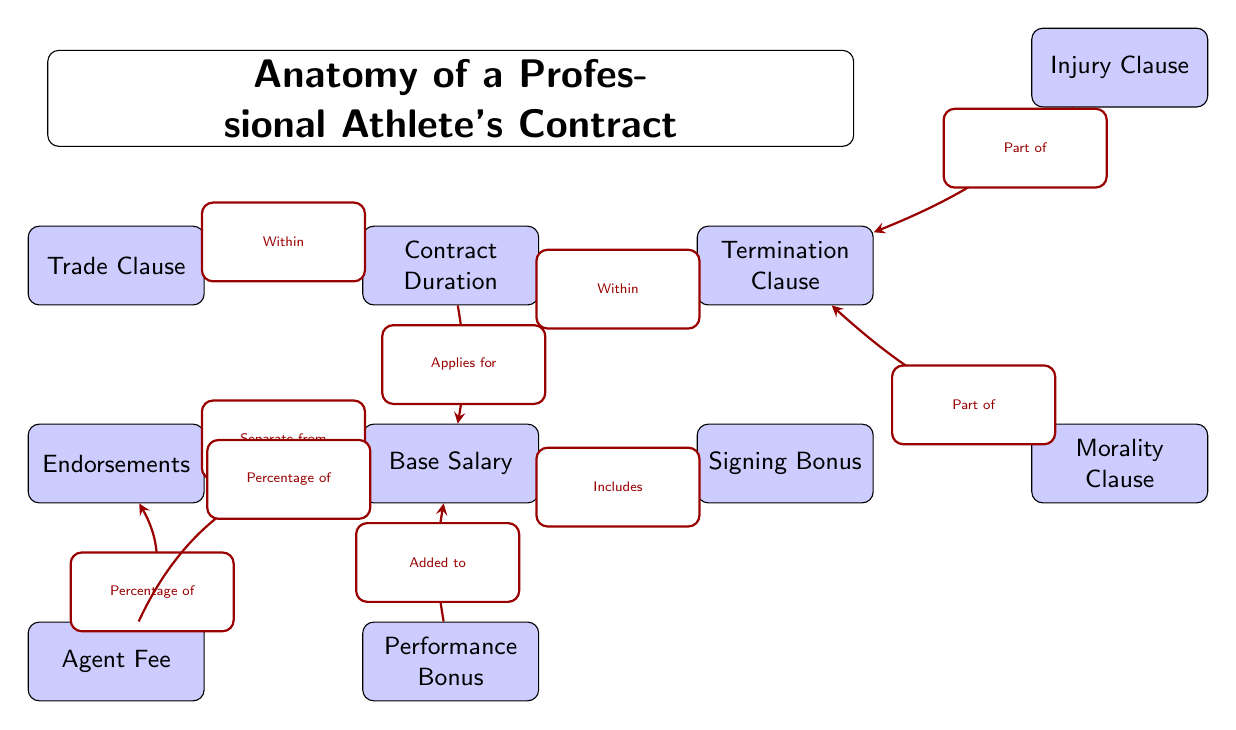What is the relationship between the signing bonus and base salary? The diagram shows an arrow labeled "Includes" pointing from the signing bonus to the base salary, indicating that the signing bonus is part of the base salary.
Answer: Includes How many clauses are part of the termination clause? The termination clause contains two clauses: injury clause and morality clause, as indicated by the arrows pointing to them from the termination clause.
Answer: Two What applies for the base salary? The diagram indicates that the contract duration applies for the base salary, as shown by the arrow labeled "Applies for."
Answer: Contract duration What percentage of endorsements does the agent fee represent? The diagram explicitly states that the agent fee is a percentage of the endorsements, as indicated by the arrow labeled "Percentage of."
Answer: Percentage of Which clause falls under the contract duration? The trade clause is indicated to be within the contract duration, as the arrow labeled "Within" directs from the contract duration to the trade clause.
Answer: Trade clause What is the function of the performance bonus in relation to the base salary? The performance bonus is shown to be added to the base salary, as indicated by the arrow labeled "Added to" pointing to the base salary from the performance bonus.
Answer: Added to How does the agent fee relate to the base salary? The diagram shows that the agent fee is a percentage of the base salary, indicated by the arrow labeled "Percentage of" leading from agent fee to base salary.
Answer: Percentage of Which two clauses are part of the termination clause? The injury clause and morality clause are noted as part of the termination clause in the diagram, as marked with arrows pointing towards them from the termination clause.
Answer: Injury clause, Morality clause How many nodes are there in total that represent financial components? The nodes representing financial components include base salary, signing bonus, performance bonus, and endorsements, totaling four distinct financial components.
Answer: Four 